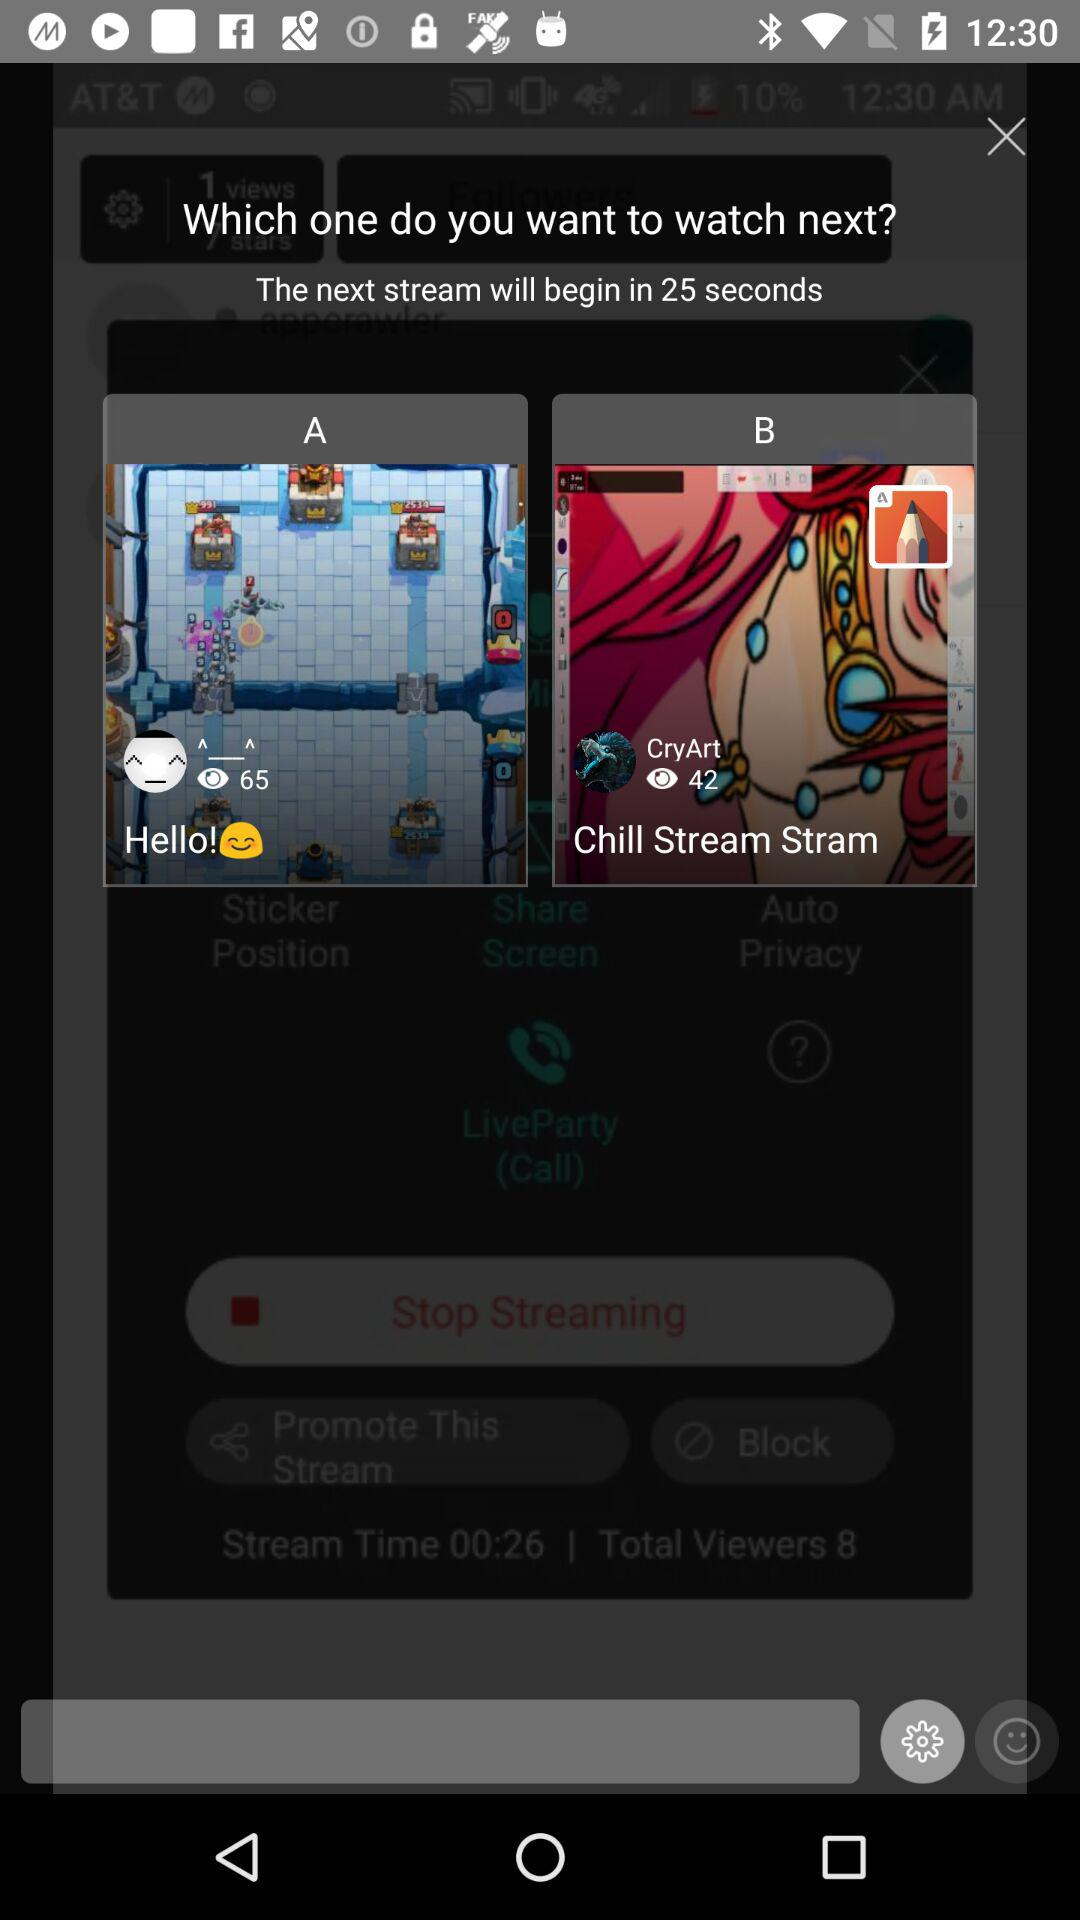How many people have viewed the "Chill Stream Stram"? There are 42 people who have viewed the "Chill Stream Stram". 